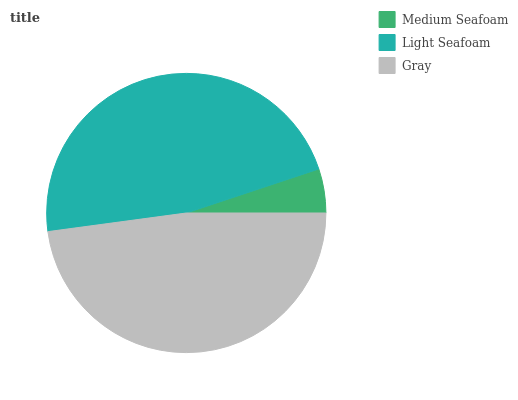Is Medium Seafoam the minimum?
Answer yes or no. Yes. Is Gray the maximum?
Answer yes or no. Yes. Is Light Seafoam the minimum?
Answer yes or no. No. Is Light Seafoam the maximum?
Answer yes or no. No. Is Light Seafoam greater than Medium Seafoam?
Answer yes or no. Yes. Is Medium Seafoam less than Light Seafoam?
Answer yes or no. Yes. Is Medium Seafoam greater than Light Seafoam?
Answer yes or no. No. Is Light Seafoam less than Medium Seafoam?
Answer yes or no. No. Is Light Seafoam the high median?
Answer yes or no. Yes. Is Light Seafoam the low median?
Answer yes or no. Yes. Is Medium Seafoam the high median?
Answer yes or no. No. Is Gray the low median?
Answer yes or no. No. 